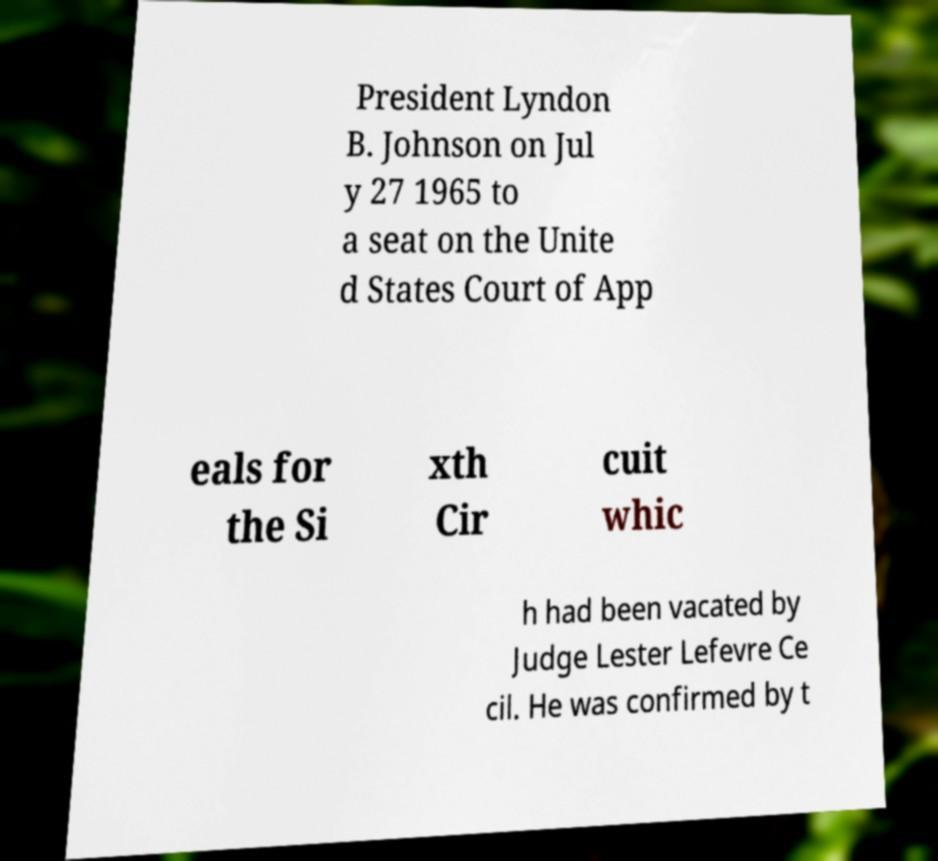I need the written content from this picture converted into text. Can you do that? President Lyndon B. Johnson on Jul y 27 1965 to a seat on the Unite d States Court of App eals for the Si xth Cir cuit whic h had been vacated by Judge Lester Lefevre Ce cil. He was confirmed by t 